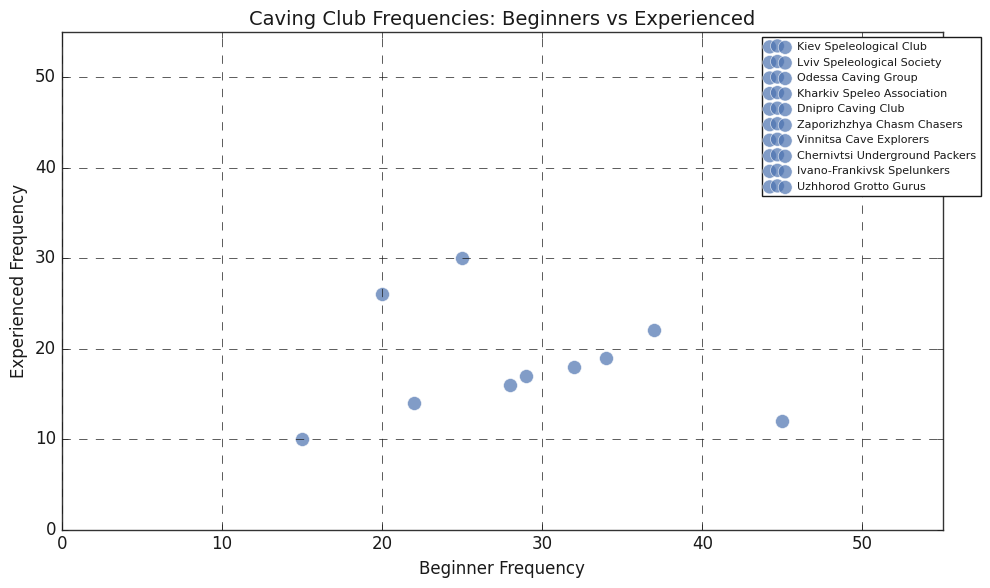What is the frequency of beginners in the Lviv Speleological Society compared to experienced members? The figure plots the frequency of "Lviv Speleological Society" for both beginners and experienced members. Simply compare the visual height (or numerical value) of the beginner's point with the experienced one.
Answer: 45 (Beginners) vs. 12 (Experienced) Which caving club has the highest number of experienced cavers? By observing the vertical positions of the experienced cavers in the scatter plot, we can find the point that reaches the highest value on the Y-axis.
Answer: Odessa Caving Group What is the sum of beginner frequencies across all caving clubs? To find the sum, we need to locate and add the frequencies for beginners from each caving club plotted on the X-axis. The sum is 32 (Kiev) + 45 (Lviv) + 25 (Odessa) + 37 (Kharkiv) + 20 (Dnipro) + 15 (Zaporizhzhya) + 28 (Vinnitsa) + 22 (Chernivtsi) + 34 (Ivano-Frankivsk) + 29 (Uzhhorod).
Answer: 287 Which caving club has the largest difference between beginner and experienced frequencies? Calculate the absolute difference between beginner and experienced frequencies for each club and identify the club with the largest value.
Answer: Lviv Speleological Society (33) Are there any caving clubs where the number of experienced cavers is higher than beginners? By comparing the positions of beginner and experienced points within each caving club, check for cases where the experienced point is higher.
Answer: Odessa Caving Group What is the average frequency of experienced cavers across all clubs? To calculate the average, sum the frequencies of experienced cavers from each caving club and divide by the total number of clubs. Sum is 18 + 12 + 30 + 22 + 26 + 10 + 16 + 14 + 19 + 17 = 184, divided by 10 clubs.
Answer: 18.4 Which caving club has almost equal numbers of beginners and experienced members? Identify clubs where the visual points for beginners and experienced members are closest to each other on the scatter plot.
Answer: Odessa Caving Group Is there any club where beginners have the smallest frequency? Identify the point with the lowest value on the X-axis assigned to a caving club representing beginners.
Answer: Zaporizhzhya Chasm Chasers 